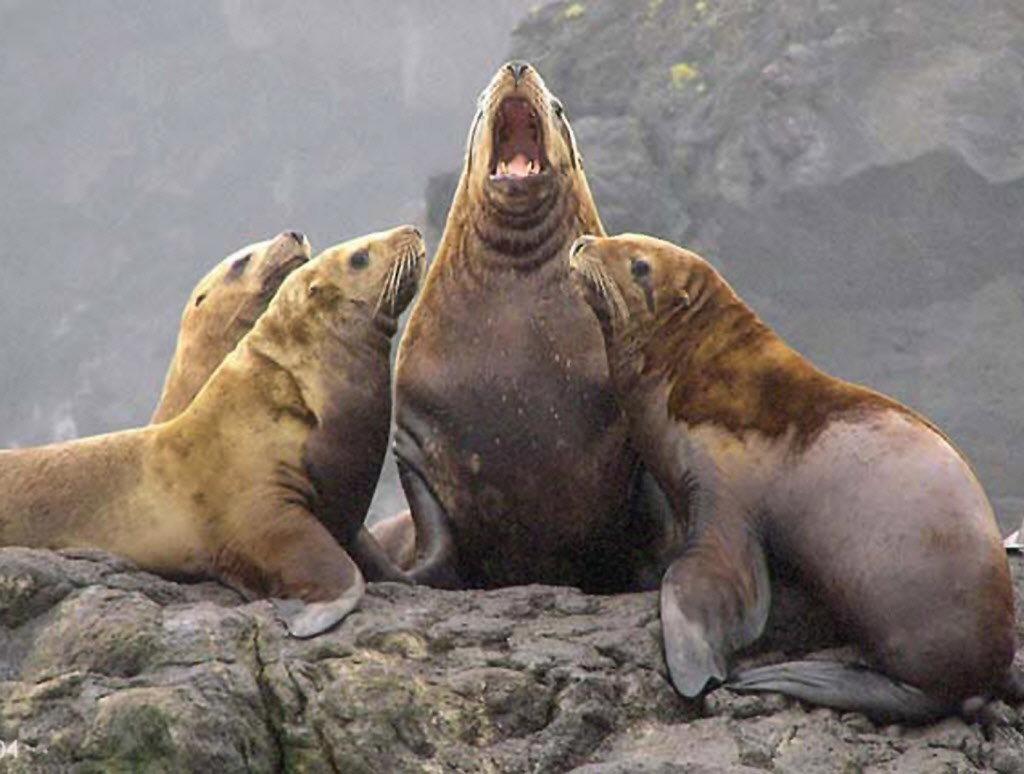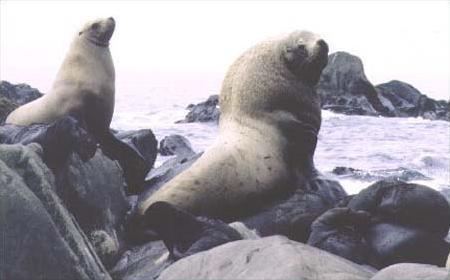The first image is the image on the left, the second image is the image on the right. For the images displayed, is the sentence "One of the images features only two seals." factually correct? Answer yes or no. Yes. 